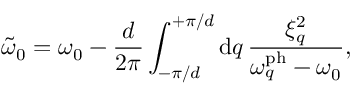Convert formula to latex. <formula><loc_0><loc_0><loc_500><loc_500>\tilde { \omega } _ { 0 } = \omega _ { 0 } - \frac { d } { 2 \pi } \int _ { - \pi / d } ^ { + \pi / d } d q \, \frac { \xi _ { q } ^ { 2 } } { \omega _ { q } ^ { p h } - \omega _ { 0 } } ,</formula> 